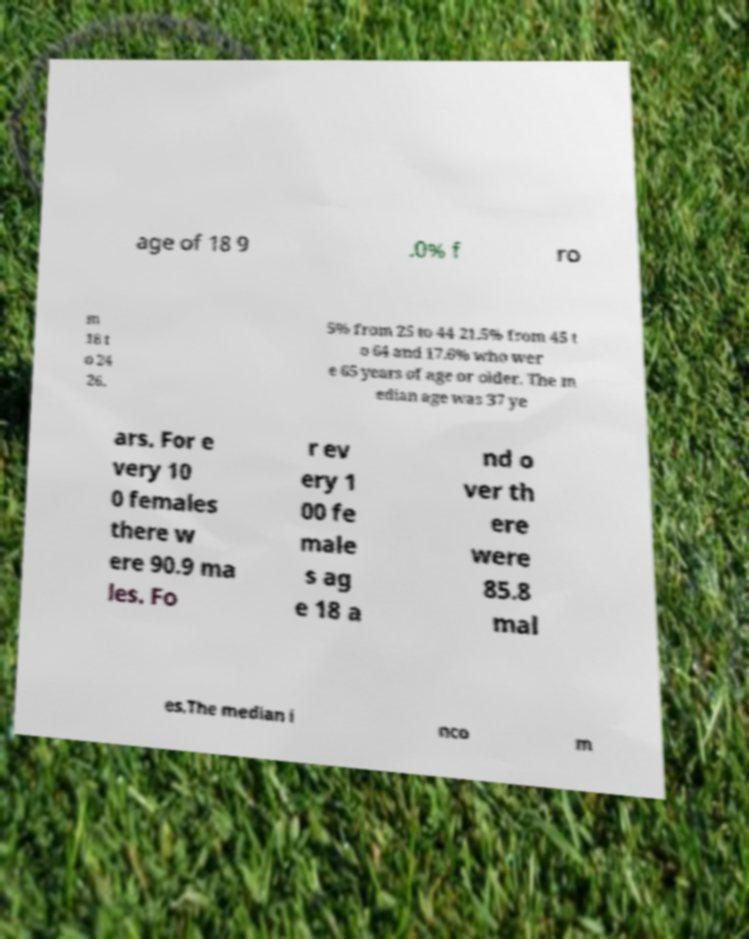Could you assist in decoding the text presented in this image and type it out clearly? age of 18 9 .0% f ro m 18 t o 24 26. 5% from 25 to 44 21.5% from 45 t o 64 and 17.6% who wer e 65 years of age or older. The m edian age was 37 ye ars. For e very 10 0 females there w ere 90.9 ma les. Fo r ev ery 1 00 fe male s ag e 18 a nd o ver th ere were 85.8 mal es.The median i nco m 